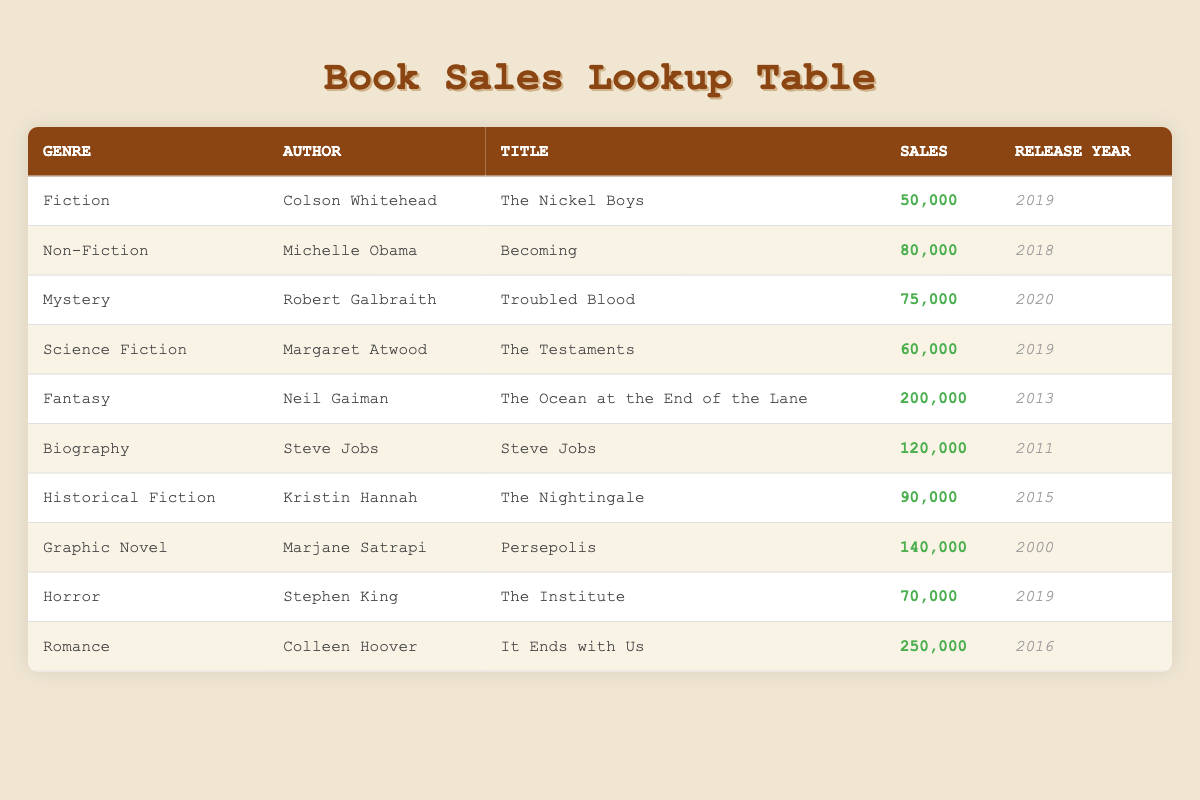What is the total sales of books in the Romance genre? The only book in the Romance genre is "It Ends with Us" by Colleen Hoover, which has sales of 250,000. Therefore, the total sales for this genre is just the sales of that single book, which is 250,000.
Answer: 250,000 Which author has the highest book sales? Colleen Hoover has the highest sales with her book "It Ends with Us," which sold 250,000 copies. None of the other authors exceed this number in total sales.
Answer: Colleen Hoover Is "The Nickel Boys" the most recent release? "The Nickel Boys" by Colson Whitehead was released in 2019. Checking the other books in the table, "Troubled Blood" released in 2020, making it more recent than "The Nickel Boys."
Answer: No What is the average sales of the books in the Mystery and Horror genres? The sales for "Troubled Blood" in the Mystery genre is 75,000, and for "The Institute" in the Horror genre, it is 70,000. Adding these sales gives 75,000 + 70,000 = 145,000. Then, dividing by 2 for the average gives 145,000 / 2 = 72,500.
Answer: 72,500 How many different genres are represented in the book sales data? The genres listed in the table are Fiction, Non-Fiction, Mystery, Science Fiction, Fantasy, Biography, Historical Fiction, Graphic Novel, Horror, and Romance, totaling 10 distinct genres.
Answer: 10 What percentage of total sales was contributed by "Becoming"? The sales of “Becoming” is 80,000. The total sales for all books is 50,000 + 80,000 + 75,000 + 60,000 + 200,000 + 120,000 + 90,000 + 140,000 + 70,000 + 250,000 = 1,055,000. To find the percentage, use (80,000 / 1,055,000) * 100 = 7.58%.
Answer: 7.58% Which books released after 2015 have sales over 70,000? The books released after 2015 are "Troubled Blood" (2020, 75,000), "The Testaments" (2019, 60,000), and "The Institute" (2019, 70,000). Among these, only "Troubled Blood" has sales over 70,000, making it the only qualifying book.
Answer: Troubled Blood What is the sum of sales for all Biography and Historical Fiction books? "Steve Jobs" in the Biography genre has sales of 120,000, and "The Nightingale" in Historical Fiction has sales of 90,000. Adding these together gives 120,000 + 90,000 = 210,000.
Answer: 210,000 Is there a Graphic Novel in the top three best-selling books? The best-selling books are "It Ends with Us" (250,000), "The Ocean at the End of the Lane" (200,000), and "Steve Jobs" (120,000). "Persepolis" by Marjane Satrapi, a Graphic Novel, has sales of 140,000, which does not place it within the top three.
Answer: No 